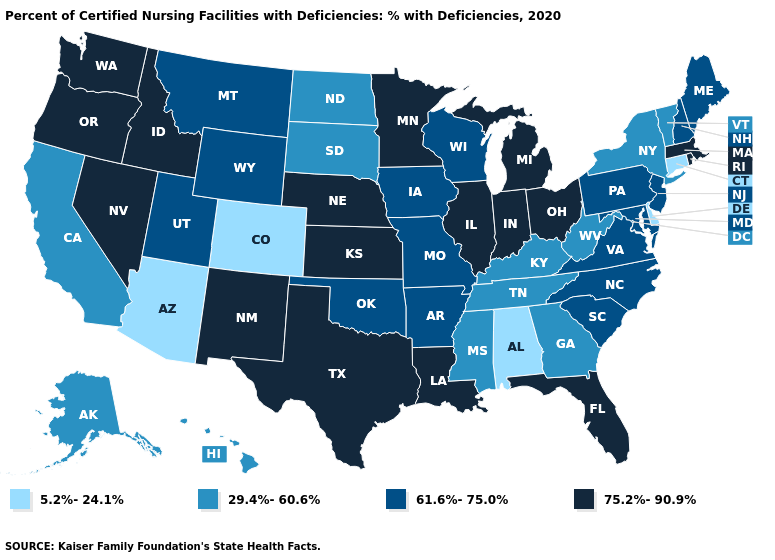Name the states that have a value in the range 5.2%-24.1%?
Give a very brief answer. Alabama, Arizona, Colorado, Connecticut, Delaware. What is the highest value in the USA?
Write a very short answer. 75.2%-90.9%. Does Connecticut have the lowest value in the Northeast?
Short answer required. Yes. Among the states that border Colorado , does Nebraska have the lowest value?
Give a very brief answer. No. Does the first symbol in the legend represent the smallest category?
Short answer required. Yes. Is the legend a continuous bar?
Concise answer only. No. What is the value of Utah?
Give a very brief answer. 61.6%-75.0%. Name the states that have a value in the range 5.2%-24.1%?
Answer briefly. Alabama, Arizona, Colorado, Connecticut, Delaware. Among the states that border New Mexico , does Texas have the highest value?
Short answer required. Yes. Which states have the lowest value in the USA?
Concise answer only. Alabama, Arizona, Colorado, Connecticut, Delaware. Name the states that have a value in the range 75.2%-90.9%?
Answer briefly. Florida, Idaho, Illinois, Indiana, Kansas, Louisiana, Massachusetts, Michigan, Minnesota, Nebraska, Nevada, New Mexico, Ohio, Oregon, Rhode Island, Texas, Washington. What is the value of New Hampshire?
Short answer required. 61.6%-75.0%. Does the map have missing data?
Quick response, please. No. Does South Dakota have the highest value in the MidWest?
Short answer required. No. Name the states that have a value in the range 75.2%-90.9%?
Give a very brief answer. Florida, Idaho, Illinois, Indiana, Kansas, Louisiana, Massachusetts, Michigan, Minnesota, Nebraska, Nevada, New Mexico, Ohio, Oregon, Rhode Island, Texas, Washington. 